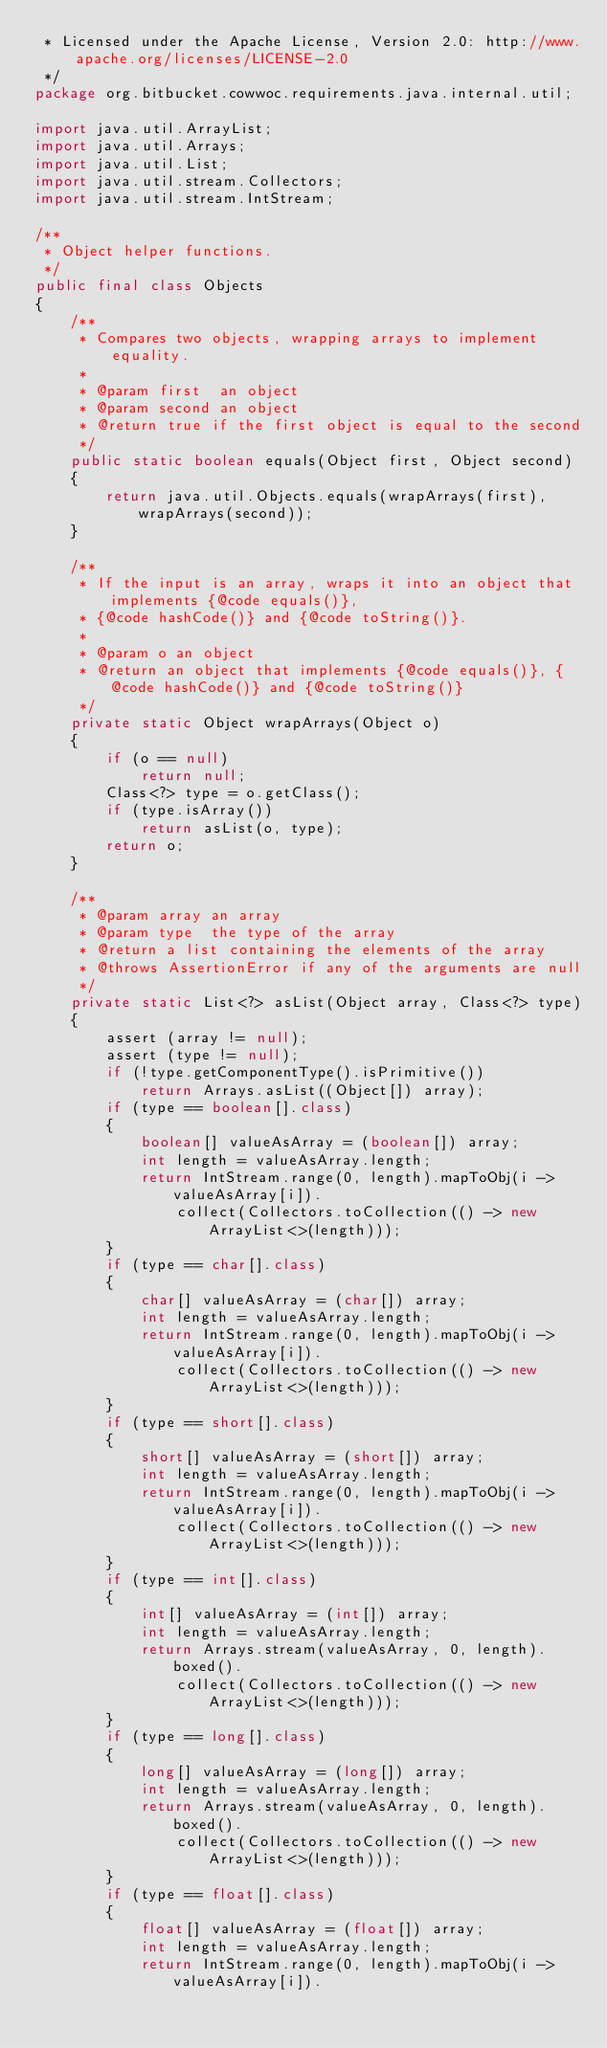Convert code to text. <code><loc_0><loc_0><loc_500><loc_500><_Java_> * Licensed under the Apache License, Version 2.0: http://www.apache.org/licenses/LICENSE-2.0
 */
package org.bitbucket.cowwoc.requirements.java.internal.util;

import java.util.ArrayList;
import java.util.Arrays;
import java.util.List;
import java.util.stream.Collectors;
import java.util.stream.IntStream;

/**
 * Object helper functions.
 */
public final class Objects
{
	/**
	 * Compares two objects, wrapping arrays to implement equality.
	 *
	 * @param first  an object
	 * @param second an object
	 * @return true if the first object is equal to the second
	 */
	public static boolean equals(Object first, Object second)
	{
		return java.util.Objects.equals(wrapArrays(first), wrapArrays(second));
	}

	/**
	 * If the input is an array, wraps it into an object that implements {@code equals()},
	 * {@code hashCode()} and {@code toString()}.
	 *
	 * @param o an object
	 * @return an object that implements {@code equals()}, {@code hashCode()} and {@code toString()}
	 */
	private static Object wrapArrays(Object o)
	{
		if (o == null)
			return null;
		Class<?> type = o.getClass();
		if (type.isArray())
			return asList(o, type);
		return o;
	}

	/**
	 * @param array an array
	 * @param type  the type of the array
	 * @return a list containing the elements of the array
	 * @throws AssertionError if any of the arguments are null
	 */
	private static List<?> asList(Object array, Class<?> type)
	{
		assert (array != null);
		assert (type != null);
		if (!type.getComponentType().isPrimitive())
			return Arrays.asList((Object[]) array);
		if (type == boolean[].class)
		{
			boolean[] valueAsArray = (boolean[]) array;
			int length = valueAsArray.length;
			return IntStream.range(0, length).mapToObj(i -> valueAsArray[i]).
				collect(Collectors.toCollection(() -> new ArrayList<>(length)));
		}
		if (type == char[].class)
		{
			char[] valueAsArray = (char[]) array;
			int length = valueAsArray.length;
			return IntStream.range(0, length).mapToObj(i -> valueAsArray[i]).
				collect(Collectors.toCollection(() -> new ArrayList<>(length)));
		}
		if (type == short[].class)
		{
			short[] valueAsArray = (short[]) array;
			int length = valueAsArray.length;
			return IntStream.range(0, length).mapToObj(i -> valueAsArray[i]).
				collect(Collectors.toCollection(() -> new ArrayList<>(length)));
		}
		if (type == int[].class)
		{
			int[] valueAsArray = (int[]) array;
			int length = valueAsArray.length;
			return Arrays.stream(valueAsArray, 0, length).boxed().
				collect(Collectors.toCollection(() -> new ArrayList<>(length)));
		}
		if (type == long[].class)
		{
			long[] valueAsArray = (long[]) array;
			int length = valueAsArray.length;
			return Arrays.stream(valueAsArray, 0, length).boxed().
				collect(Collectors.toCollection(() -> new ArrayList<>(length)));
		}
		if (type == float[].class)
		{
			float[] valueAsArray = (float[]) array;
			int length = valueAsArray.length;
			return IntStream.range(0, length).mapToObj(i -> valueAsArray[i]).</code> 